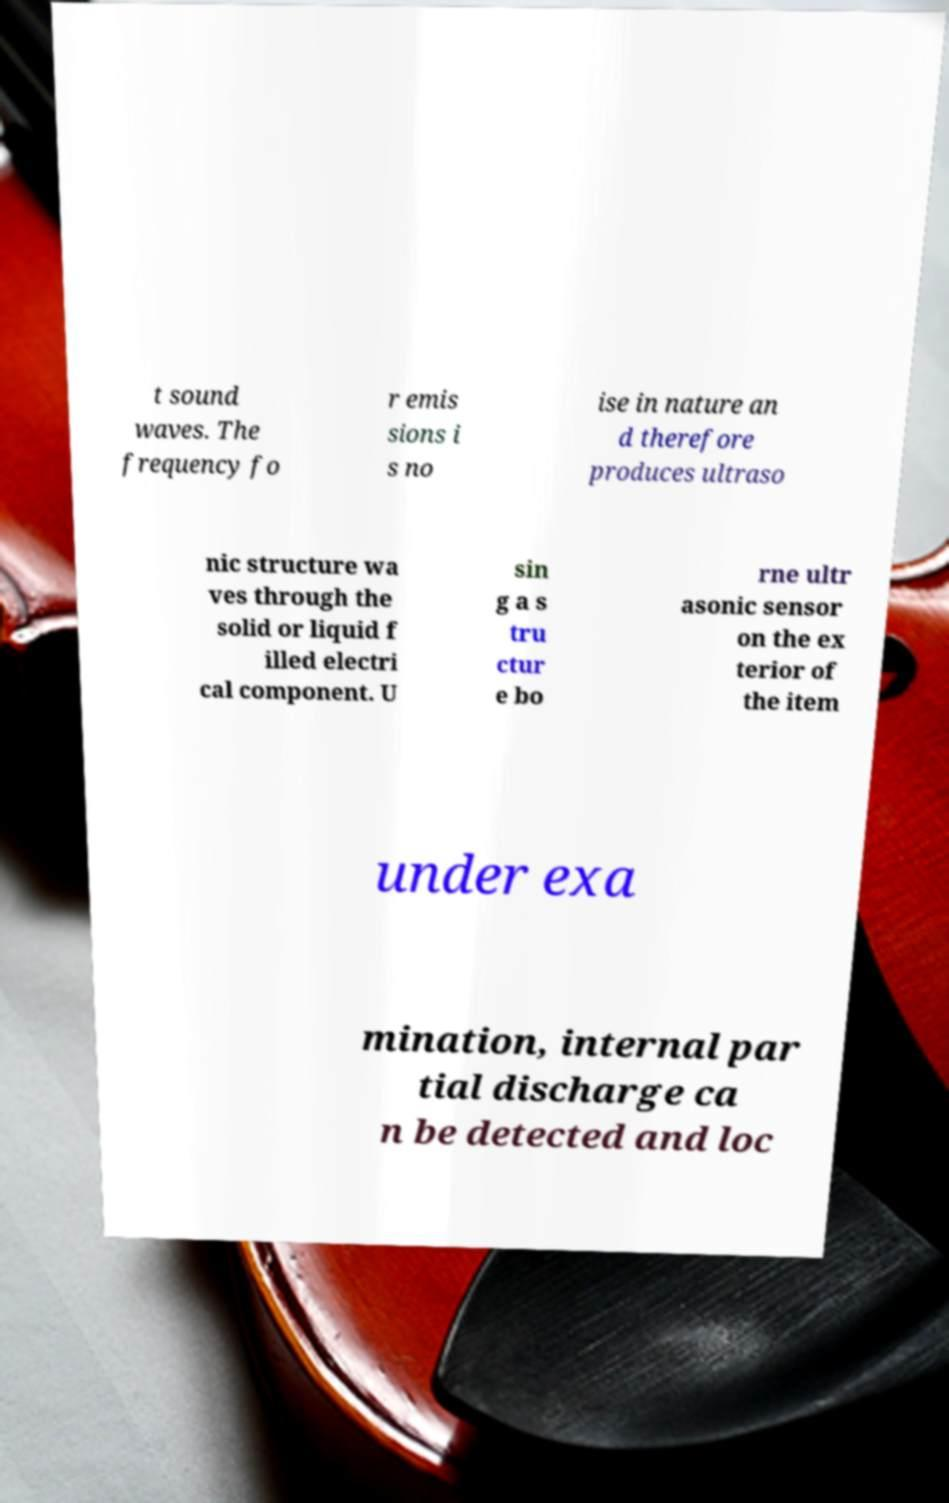There's text embedded in this image that I need extracted. Can you transcribe it verbatim? t sound waves. The frequency fo r emis sions i s no ise in nature an d therefore produces ultraso nic structure wa ves through the solid or liquid f illed electri cal component. U sin g a s tru ctur e bo rne ultr asonic sensor on the ex terior of the item under exa mination, internal par tial discharge ca n be detected and loc 